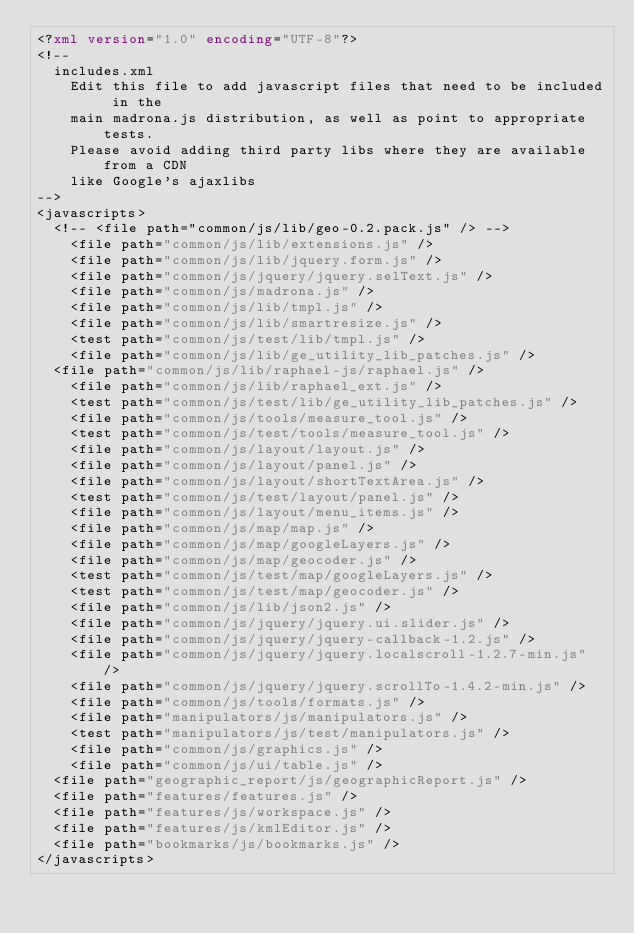Convert code to text. <code><loc_0><loc_0><loc_500><loc_500><_XML_><?xml version="1.0" encoding="UTF-8"?>
<!--
	includes.xml
    Edit this file to add javascript files that need to be included in the
    main madrona.js distribution, as well as point to appropriate tests.
    Please avoid adding third party libs where they are available from a CDN        
    like Google's ajaxlibs
-->
<javascripts>
  <!-- <file path="common/js/lib/geo-0.2.pack.js" /> -->
    <file path="common/js/lib/extensions.js" />
    <file path="common/js/lib/jquery.form.js" />
    <file path="common/js/jquery/jquery.selText.js" />
    <file path="common/js/madrona.js" />
    <file path="common/js/lib/tmpl.js" />
    <file path="common/js/lib/smartresize.js" />
    <test path="common/js/test/lib/tmpl.js" />
    <file path="common/js/lib/ge_utility_lib_patches.js" />
	<file path="common/js/lib/raphael-js/raphael.js" />
    <file path="common/js/lib/raphael_ext.js" />
    <test path="common/js/test/lib/ge_utility_lib_patches.js" />
    <file path="common/js/tools/measure_tool.js" />
    <test path="common/js/test/tools/measure_tool.js" />
    <file path="common/js/layout/layout.js" />
    <file path="common/js/layout/panel.js" />
    <file path="common/js/layout/shortTextArea.js" />
    <test path="common/js/test/layout/panel.js" />
    <file path="common/js/layout/menu_items.js" />
    <file path="common/js/map/map.js" />
    <file path="common/js/map/googleLayers.js" />
    <file path="common/js/map/geocoder.js" />
    <test path="common/js/test/map/googleLayers.js" />
    <test path="common/js/test/map/geocoder.js" />
    <file path="common/js/lib/json2.js" />
    <file path="common/js/jquery/jquery.ui.slider.js" />
    <file path="common/js/jquery/jquery-callback-1.2.js" />
    <file path="common/js/jquery/jquery.localscroll-1.2.7-min.js" />
    <file path="common/js/jquery/jquery.scrollTo-1.4.2-min.js" />
    <file path="common/js/tools/formats.js" />
    <file path="manipulators/js/manipulators.js" />
    <test path="manipulators/js/test/manipulators.js" />
    <file path="common/js/graphics.js" />
    <file path="common/js/ui/table.js" />
	<file path="geographic_report/js/geographicReport.js" />
	<file path="features/features.js" />
	<file path="features/js/workspace.js" />
	<file path="features/js/kmlEditor.js" />	
	<file path="bookmarks/js/bookmarks.js" />	
</javascripts>
</code> 